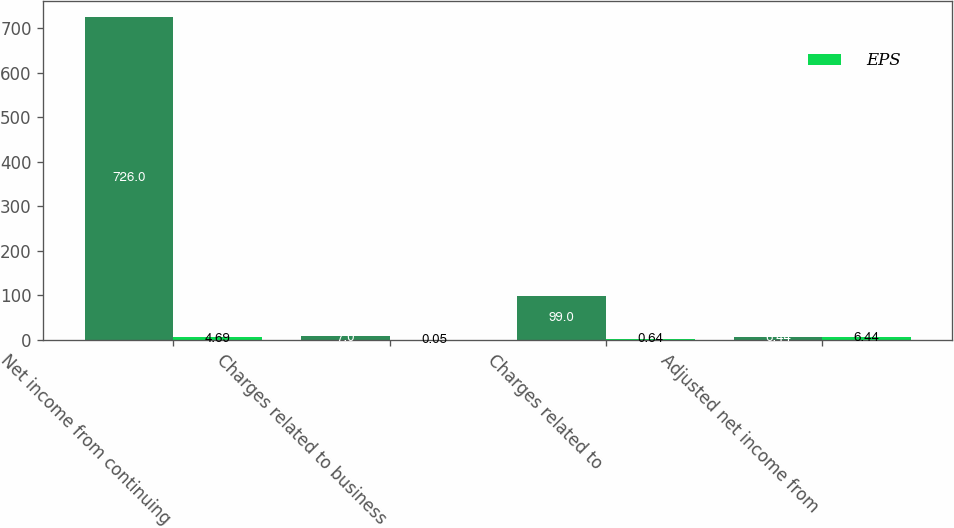Convert chart. <chart><loc_0><loc_0><loc_500><loc_500><stacked_bar_chart><ecel><fcel>Net income from continuing<fcel>Charges related to business<fcel>Charges related to<fcel>Adjusted net income from<nl><fcel>nan<fcel>726<fcel>7<fcel>99<fcel>6.44<nl><fcel>EPS<fcel>4.69<fcel>0.05<fcel>0.64<fcel>6.44<nl></chart> 